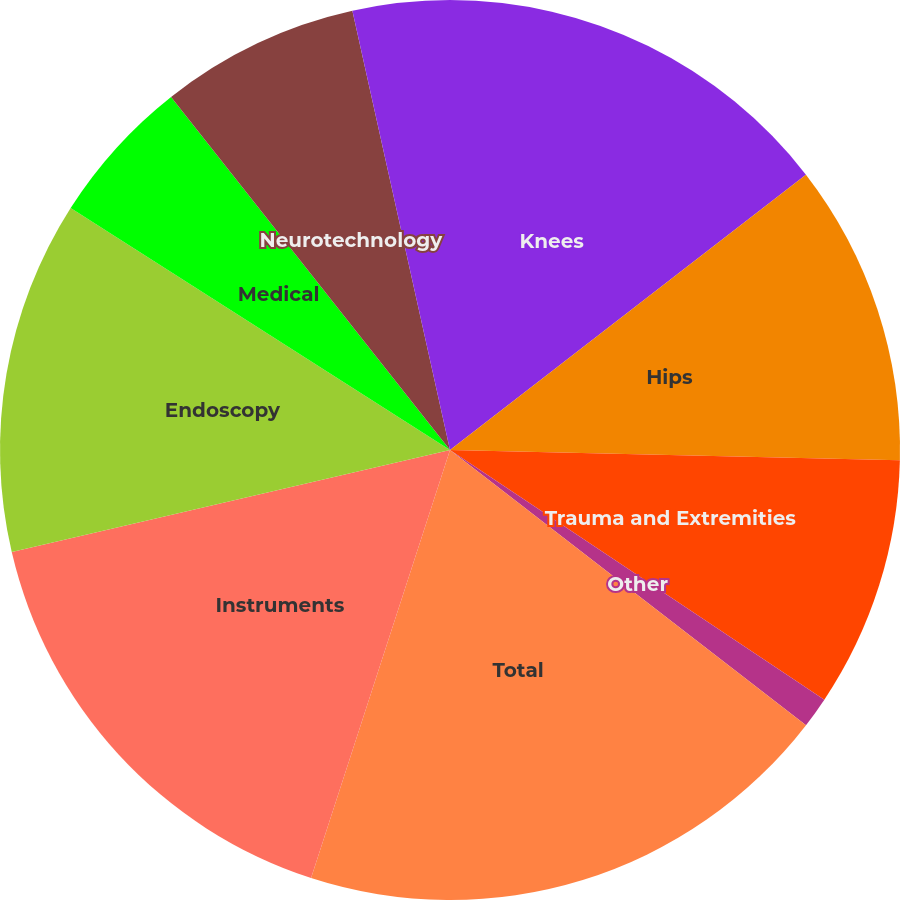<chart> <loc_0><loc_0><loc_500><loc_500><pie_chart><fcel>Knees<fcel>Hips<fcel>Trauma and Extremities<fcel>Other<fcel>Total<fcel>Instruments<fcel>Endoscopy<fcel>Medical<fcel>Neurotechnology<fcel>Spine<nl><fcel>14.52%<fcel>10.84%<fcel>9.0%<fcel>1.11%<fcel>19.52%<fcel>16.36%<fcel>12.68%<fcel>5.32%<fcel>7.16%<fcel>3.48%<nl></chart> 